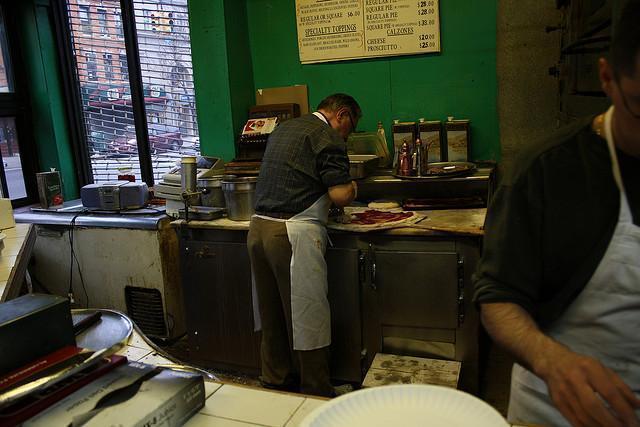Who regularly wore the item the man has over his pants?
Choose the correct response, then elucidate: 'Answer: answer
Rationale: rationale.'
Options: Man ray, ray charles, ray lewis, rachel ray. Answer: rachel ray.
Rationale: Rachel ray is a chef. 